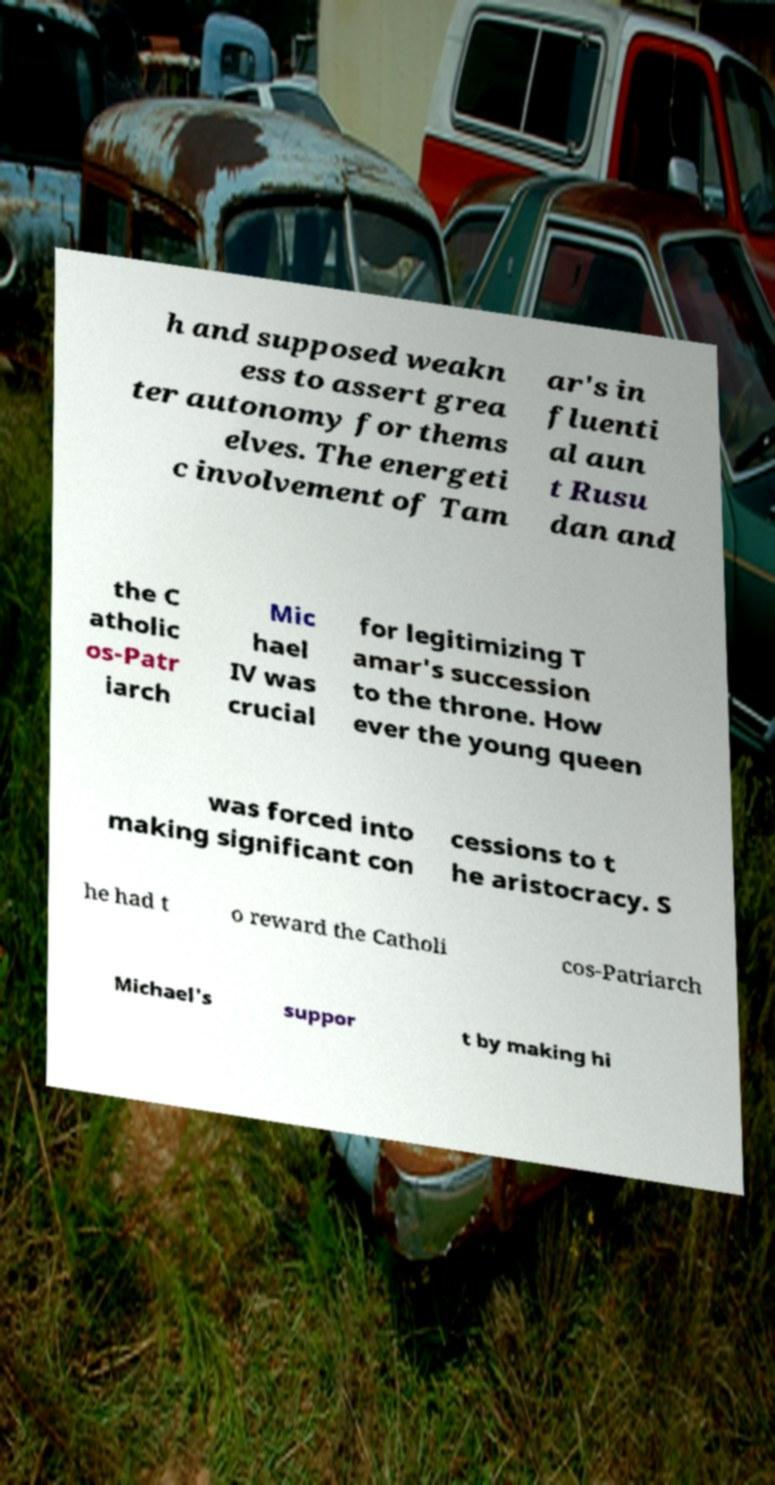Can you accurately transcribe the text from the provided image for me? h and supposed weakn ess to assert grea ter autonomy for thems elves. The energeti c involvement of Tam ar's in fluenti al aun t Rusu dan and the C atholic os-Patr iarch Mic hael IV was crucial for legitimizing T amar's succession to the throne. How ever the young queen was forced into making significant con cessions to t he aristocracy. S he had t o reward the Catholi cos-Patriarch Michael's suppor t by making hi 